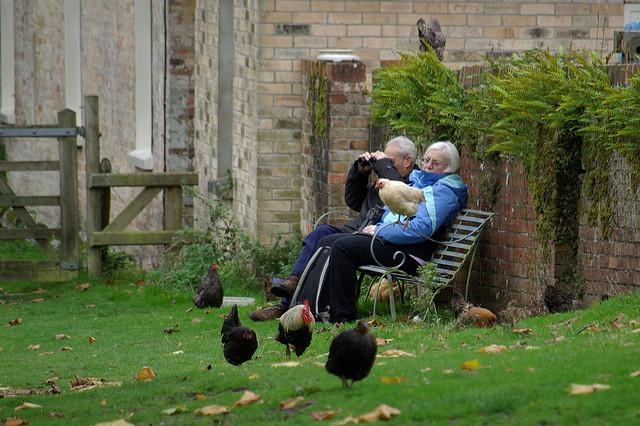What is the freshest food available to this woman? Please explain your reasoning. eggs. There are many live chickens walking around, and chickens can lay eggs for humans to consume. 